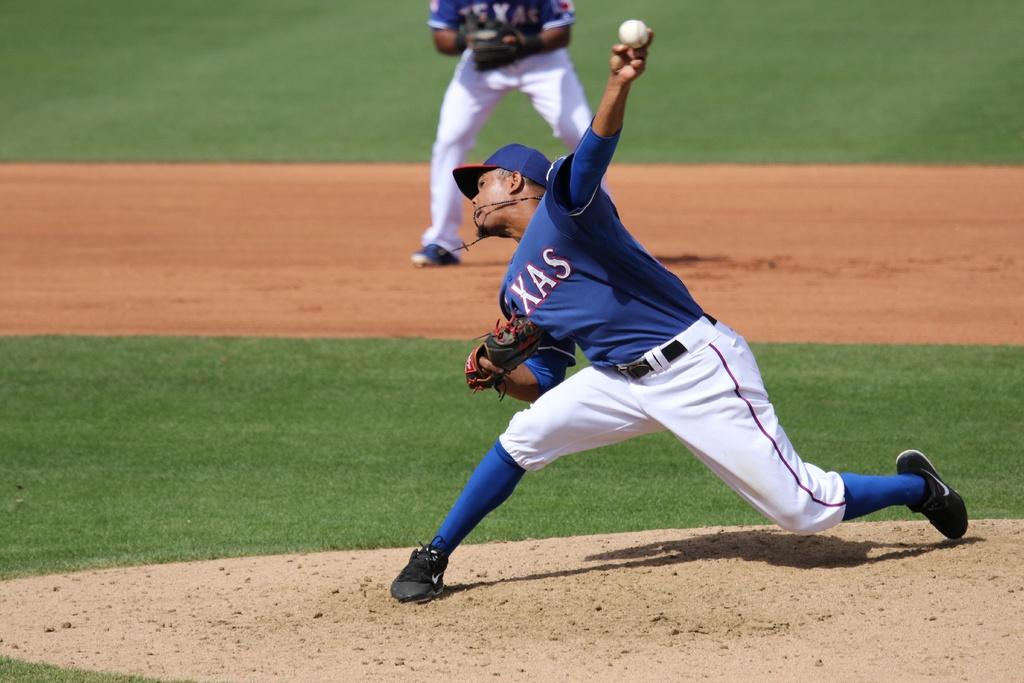<image>
Create a compact narrative representing the image presented. A baseball player for Texas prepares to throw the ball. 